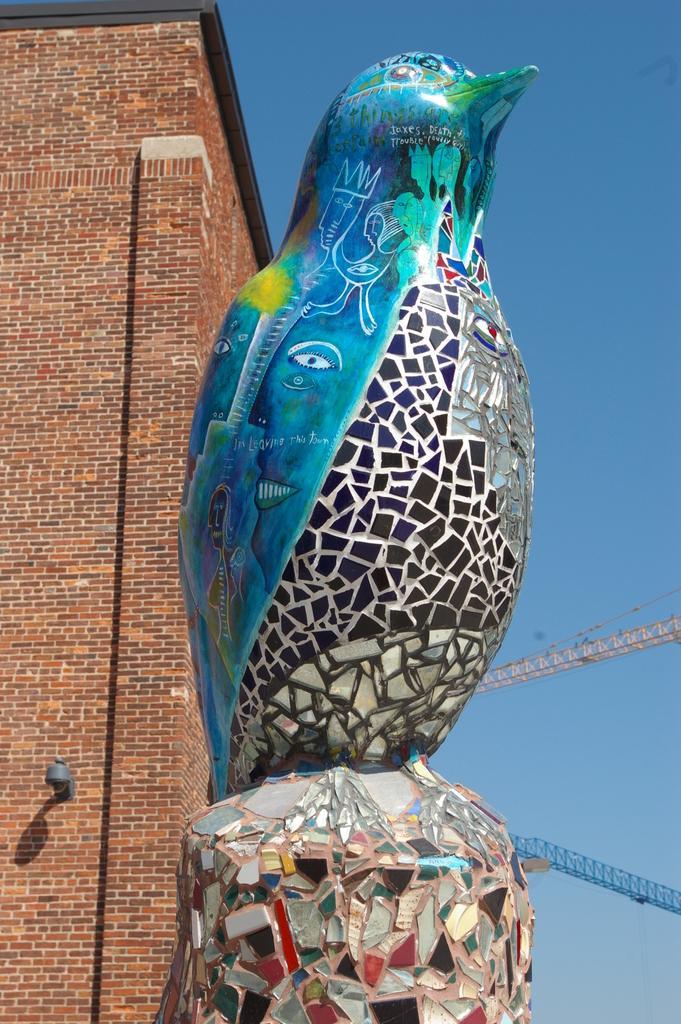Could you give a brief overview of what you see in this image? In the picture I can see a statue of a bird. In the background I can see a building, the sky and some other objects. 